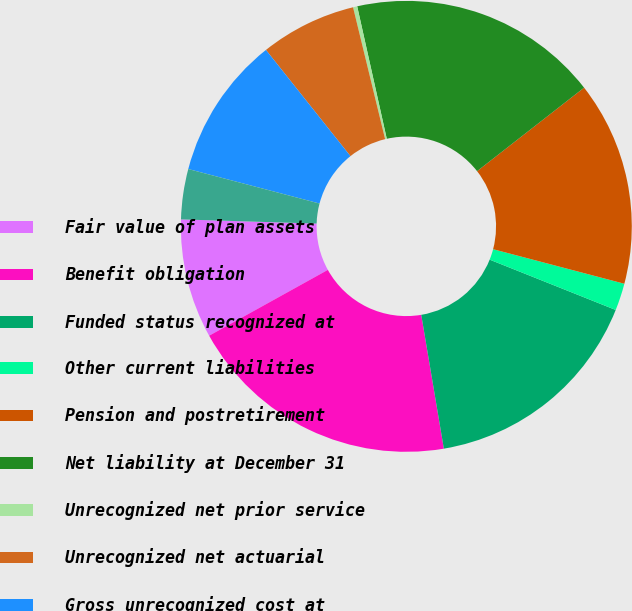Convert chart to OTSL. <chart><loc_0><loc_0><loc_500><loc_500><pie_chart><fcel>Fair value of plan assets<fcel>Benefit obligation<fcel>Funded status recognized at<fcel>Other current liabilities<fcel>Pension and postretirement<fcel>Net liability at December 31<fcel>Unrecognized net prior service<fcel>Unrecognized net actuarial<fcel>Gross unrecognized cost at<fcel>Deferred tax asset at December<nl><fcel>8.55%<fcel>19.6%<fcel>16.29%<fcel>1.95%<fcel>14.64%<fcel>17.95%<fcel>0.3%<fcel>6.9%<fcel>10.21%<fcel>3.6%<nl></chart> 